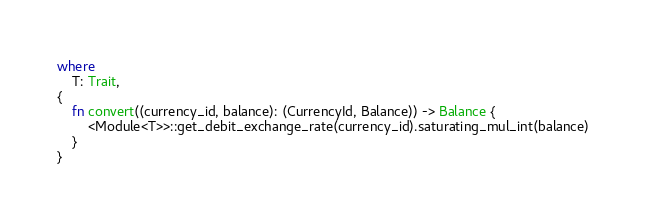<code> <loc_0><loc_0><loc_500><loc_500><_Rust_>where
	T: Trait,
{
	fn convert((currency_id, balance): (CurrencyId, Balance)) -> Balance {
		<Module<T>>::get_debit_exchange_rate(currency_id).saturating_mul_int(balance)
	}
}
</code> 